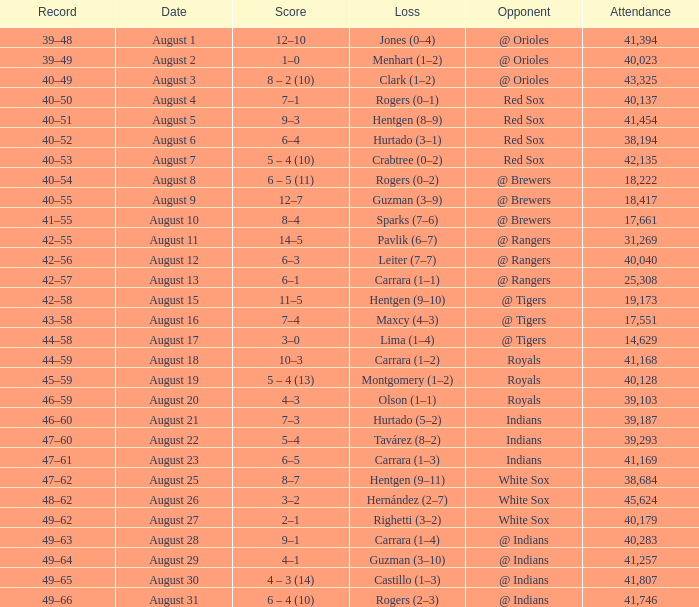Who did they play on August 12? @ Rangers. 